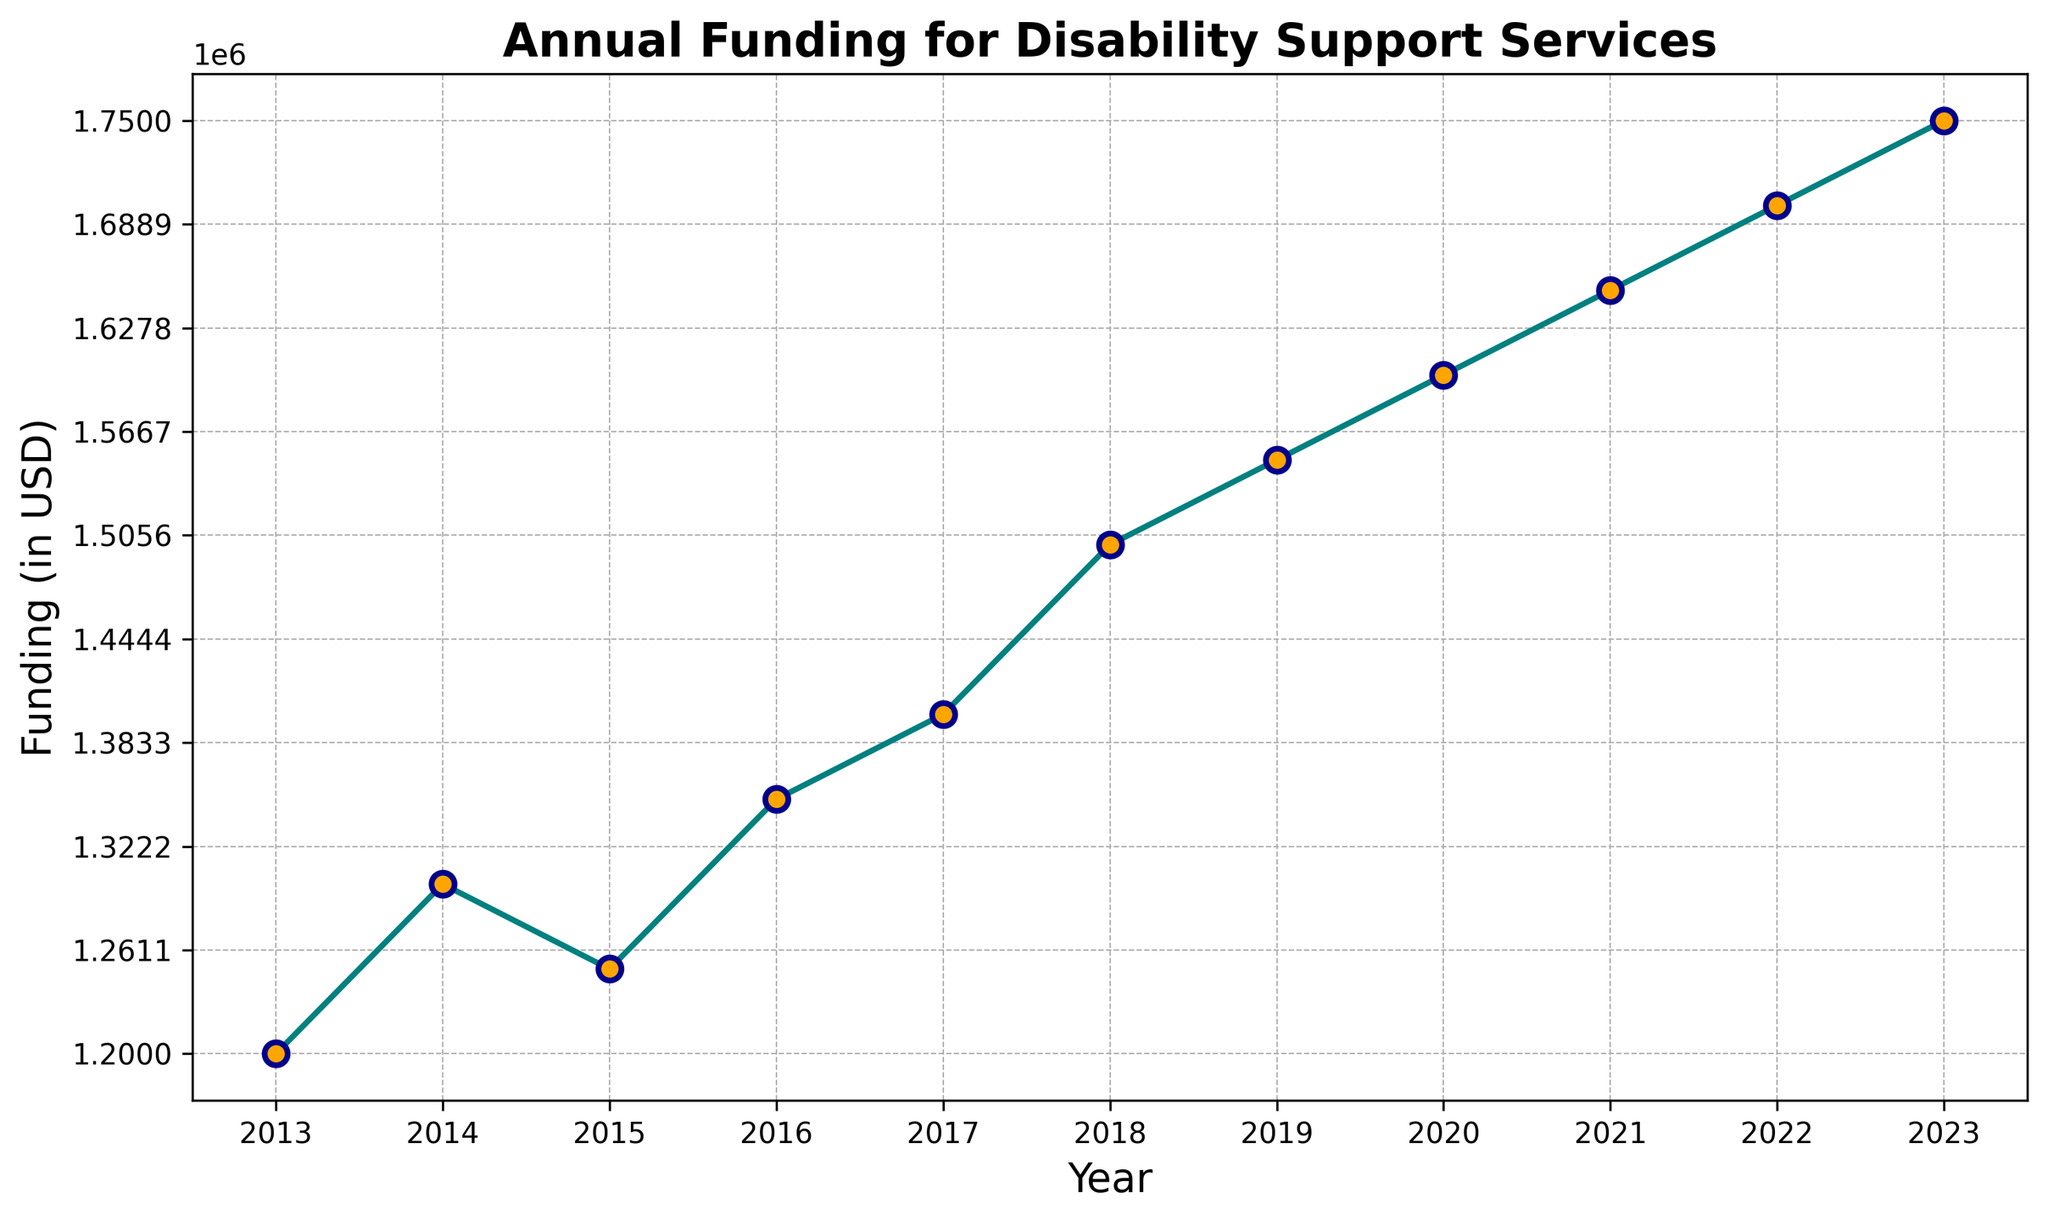What was the annual funding for disability support services in 2015? Locate the point corresponding to the year 2015 on the x-axis and read the value on the y-axis.
Answer: 1250000 Which year saw the highest increase in funding compared to the previous year? Calculate the difference in funding between each consecutive year and identify the year with the largest increase. The differences are: (2014-2013: 100000, 2015-2014: -50000, 2016-2015: 100000, 2017-2016: 50000, 2018-2017: 100000, 2019-2018: 50000, 2020-2019: 50000, 2021-2020: 50000, 2022-2021: 50000, 2023-2022: 50000). The highest increase is between 2013 and 2014.
Answer: 2014 What is the average funding over the decade? Sum the annual funding for each year and divide by the number of years (10). The sum is (1200000 + 1300000 + 1250000 + 1350000 + 1400000 + 1500000 + 1550000 + 1600000 + 1650000 + 1700000 + 1750000) = 15200000. The average is 15200000 / 10 = 1520000.
Answer: 1520000 Compare the funding between the years 2016 and 2019 — which year had higher funding and by how much? Locate the funding values for 2016 and 2019 on the y-axis. The funding for 2016 was 1350000 and for 2019 was 1550000. Subtract 1350000 from 1550000.
Answer: 2019 had higher funding by 200000 What is the funding trend from 2020 to 2023? Observe the line graph from 2020 to 2023. Note the direction of the line segment. The funding increases every year from 1600000 in 2020 to 1750000 in 2023, which indicates an upward trend.
Answer: Upward trend What is the total increase in funding from 2013 to 2023? Subtract the funding amount in 2013 from the funding amount in 2023. The funding in 2013 was 1200000 and the funding in 2023 was 1750000. The difference is 1750000 - 1200000 = 550000.
Answer: 550000 What is the median funding value over the decade? List the funding values in ascending order and find the middle value. If there is an even number of data points, the median is the average of the two middle values. The sorted values are (1200000, 1250000, 1300000, 1350000, 1400000, 1500000, 1550000, 1600000, 1650000, 1700000, 1750000). The middle value is the 6th value (1400000).
Answer: 1400000 From the figure, which year has a noticeable visual attribute, such as the change in marker color? Observe the markers on the graph. All markers have the same color and style, with teal line connecting orange markers with dark blue edges. Each year is represented similarly.
Answer: Not applicable Identify the year when a slight funding decrease occurred. Look at the plot for any year-to-year drops in the funding amount. The only decrease is from 2014 to 2015, where it goes from 1300000 to 1250000.
Answer: 2015 